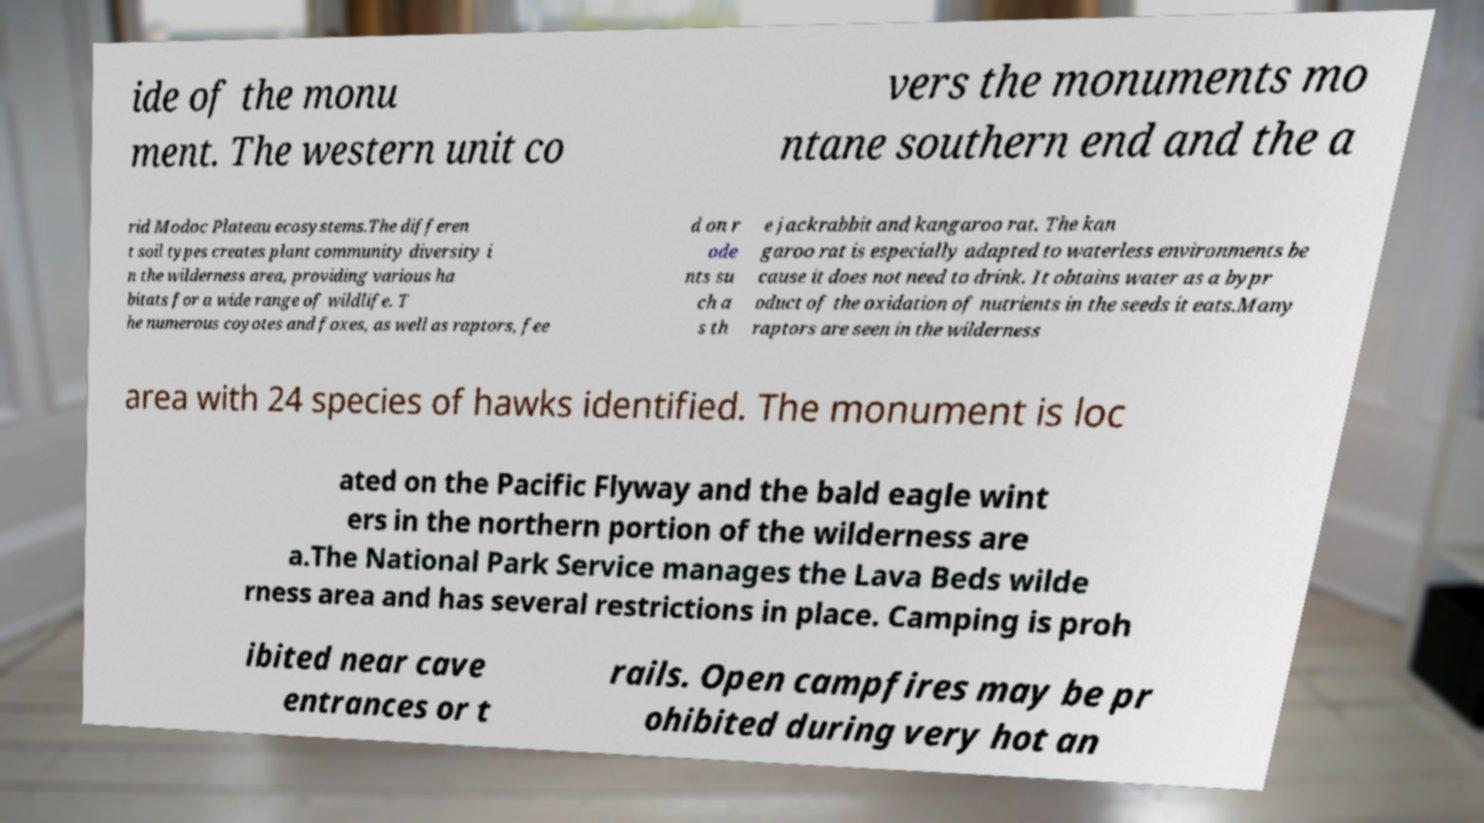Can you read and provide the text displayed in the image?This photo seems to have some interesting text. Can you extract and type it out for me? ide of the monu ment. The western unit co vers the monuments mo ntane southern end and the a rid Modoc Plateau ecosystems.The differen t soil types creates plant community diversity i n the wilderness area, providing various ha bitats for a wide range of wildlife. T he numerous coyotes and foxes, as well as raptors, fee d on r ode nts su ch a s th e jackrabbit and kangaroo rat. The kan garoo rat is especially adapted to waterless environments be cause it does not need to drink. It obtains water as a bypr oduct of the oxidation of nutrients in the seeds it eats.Many raptors are seen in the wilderness area with 24 species of hawks identified. The monument is loc ated on the Pacific Flyway and the bald eagle wint ers in the northern portion of the wilderness are a.The National Park Service manages the Lava Beds wilde rness area and has several restrictions in place. Camping is proh ibited near cave entrances or t rails. Open campfires may be pr ohibited during very hot an 